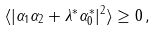Convert formula to latex. <formula><loc_0><loc_0><loc_500><loc_500>\langle | \alpha _ { 1 } \alpha _ { 2 } + \lambda ^ { * } \alpha _ { 0 } ^ { * } | ^ { 2 } \rangle \geq 0 \, ,</formula> 